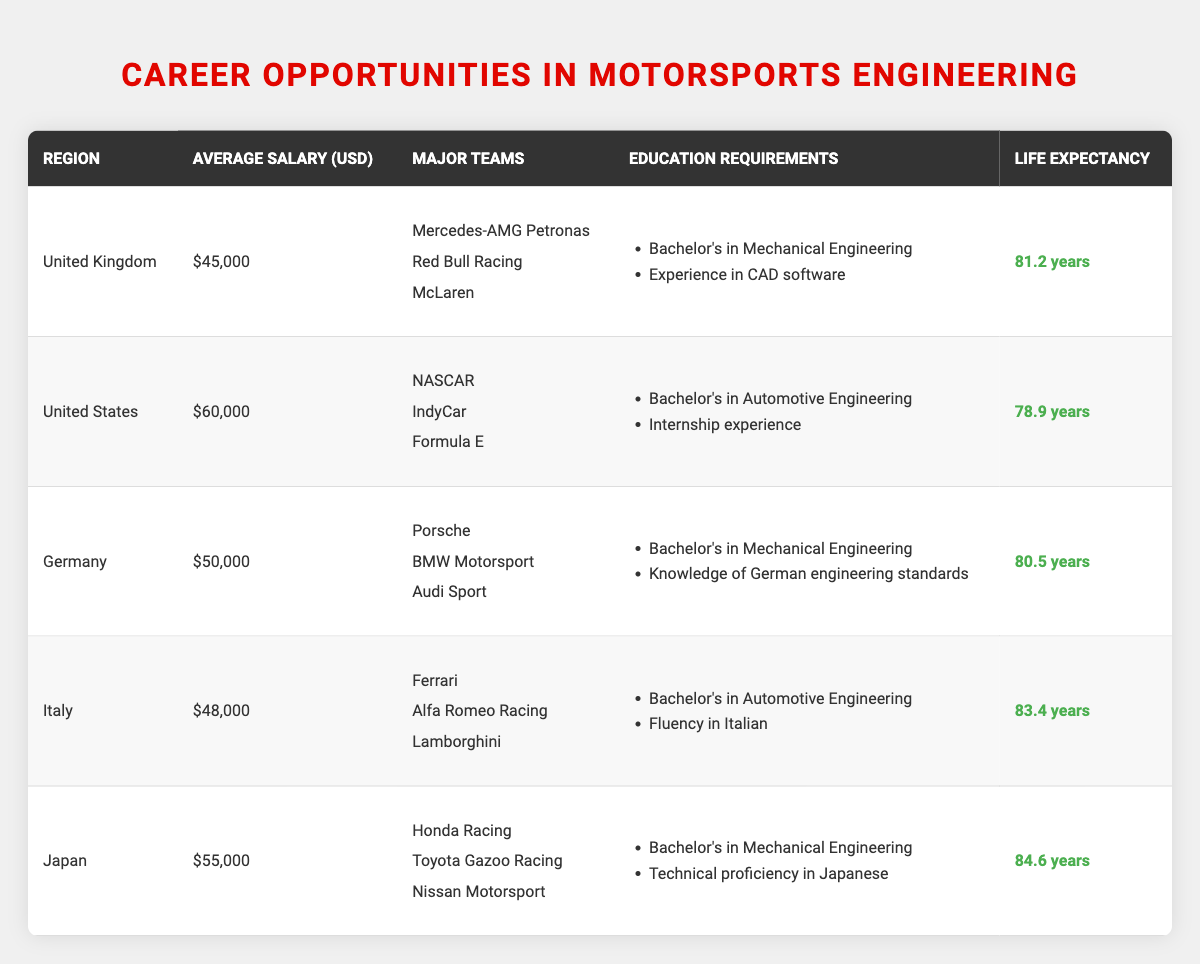What is the average salary for motorsports engineering in the United States? The table states that the average salary in the United States is $60,000.
Answer: $60,000 Which region has the highest life expectancy? Based on the table, Japan has the highest life expectancy at 84.6 years.
Answer: Japan How many major teams are listed for Germany? The table shows that Germany has three major teams listed: Porsche, BMW Motorsport, and Audi Sport.
Answer: 3 What is the difference in average salary between the United Kingdom and Italy? The average salary in the United Kingdom is $45,000, and in Italy, it is $48,000. The difference is $48,000 - $45,000 = $3,000.
Answer: $3,000 Is it true that all regions listed require a Bachelor's degree in either Mechanical or Automotive Engineering? Yes, all regions in the table specify that a Bachelor's degree is required, either in Mechanical or Automotive Engineering.
Answer: Yes What is the average life expectancy of motorsports engineers across all the regions listed? To find the average life expectancy, sum all the values: 81.2 + 78.9 + 80.5 + 83.4 + 84.6 = 408.6. Then divide by the number of regions (5): 408.6 / 5 = 81.72 years.
Answer: 81.72 years Which region requires fluency in a specific language as part of the education requirements? The table indicates that Italy requires fluency in Italian as part of the education requirements.
Answer: Italy How does the average salary in Japan compare to that in Germany? The average salary in Japan is $55,000 and in Germany is $50,000. Japan's salary is $55,000 - $50,000 = $5,000 higher than Germany's.
Answer: $5,000 higher Which region has the second highest life expectancy? To determine this, compare the life expectancies listed: Italy has 83.4 years, which is the second highest after Japan's 84.6 years.
Answer: Italy 